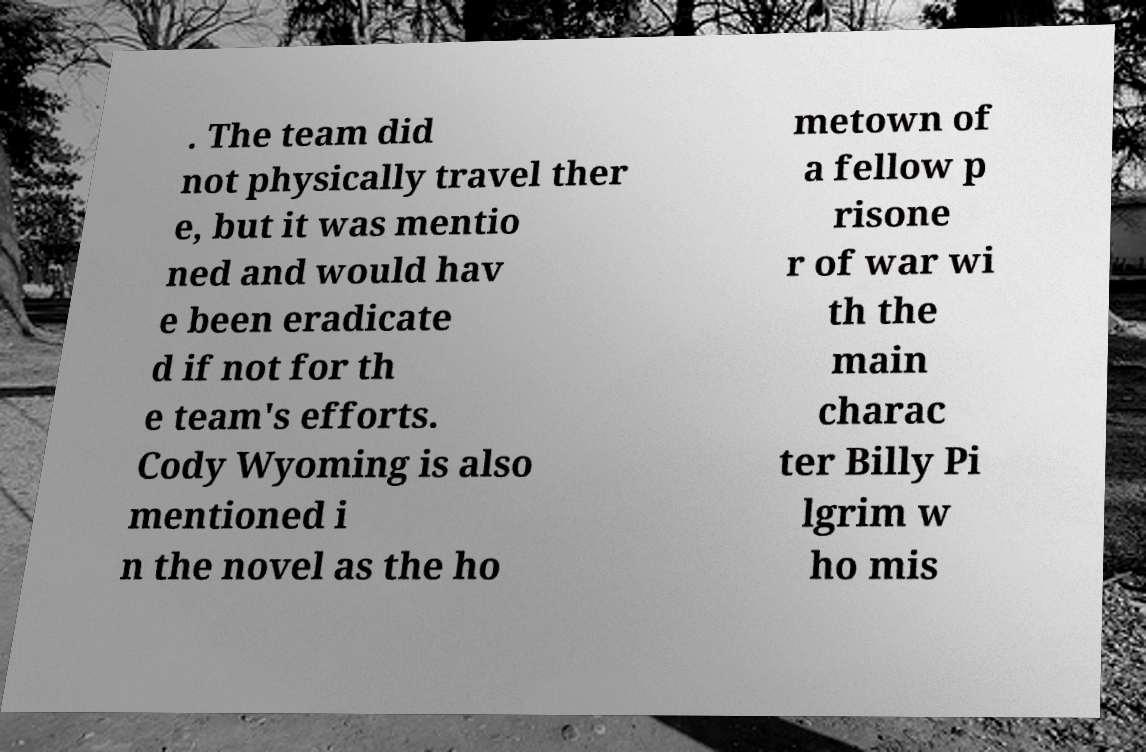Can you read and provide the text displayed in the image?This photo seems to have some interesting text. Can you extract and type it out for me? . The team did not physically travel ther e, but it was mentio ned and would hav e been eradicate d if not for th e team's efforts. Cody Wyoming is also mentioned i n the novel as the ho metown of a fellow p risone r of war wi th the main charac ter Billy Pi lgrim w ho mis 